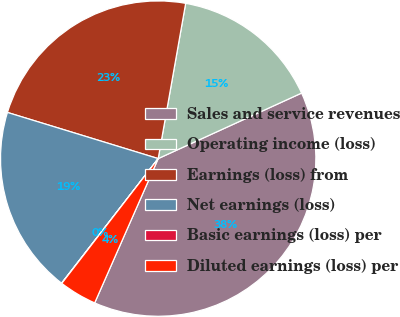<chart> <loc_0><loc_0><loc_500><loc_500><pie_chart><fcel>Sales and service revenues<fcel>Operating income (loss)<fcel>Earnings (loss) from<fcel>Net earnings (loss)<fcel>Basic earnings (loss) per<fcel>Diluted earnings (loss) per<nl><fcel>38.42%<fcel>15.39%<fcel>23.06%<fcel>19.23%<fcel>0.03%<fcel>3.87%<nl></chart> 